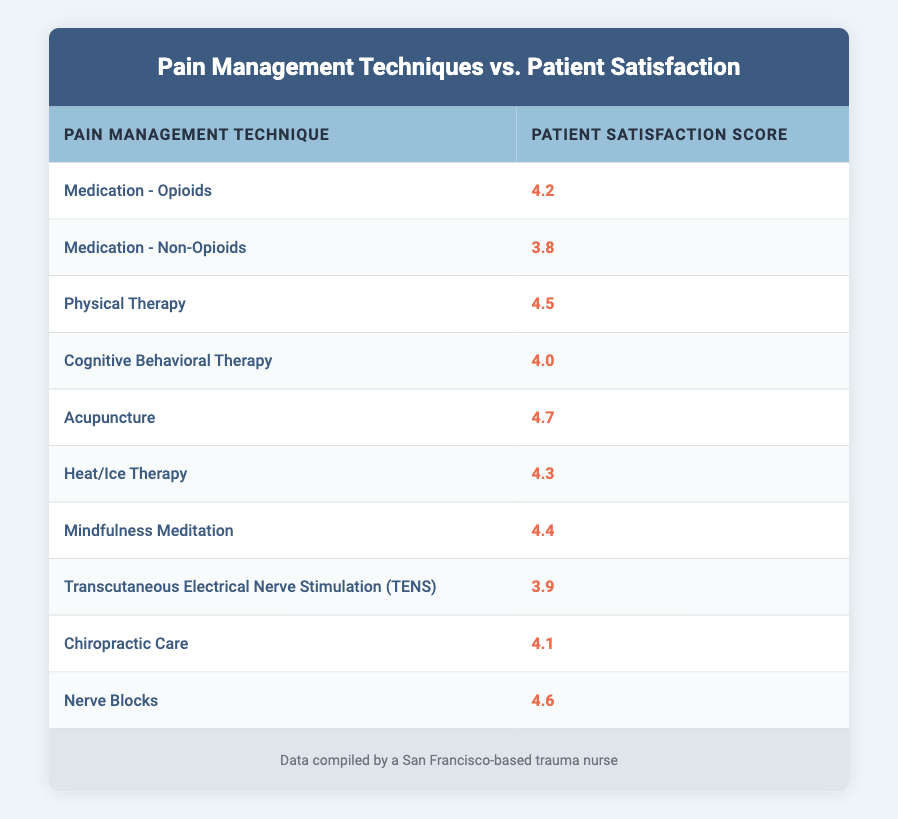What is the patient satisfaction score for Acupuncture? The table lists Acupuncture with a patient satisfaction score of 4.7, which is explicitly stated in the relevant row.
Answer: 4.7 What is the lowest patient satisfaction score among the pain management techniques? By examining the scores presented, the lowest score is 3.8, attributed to Medication - Non-Opioids in the table.
Answer: 3.8 Which pain management technique has a patient satisfaction score of 4.5? Reviewing the table, Physical Therapy is listed with a score of 4.5, thus answering the question directly.
Answer: Physical Therapy Is the patient satisfaction score for Heat/Ice Therapy higher than 4.0? The score for Heat/Ice Therapy is 4.3; since 4.3 is greater than 4.0, the answer is confirmed to be yes.
Answer: Yes What is the average patient satisfaction score for all techniques listed in the table? First, sum all the scores: 4.2 + 3.8 + 4.5 + 4.0 + 4.7 + 4.3 + 4.4 + 3.9 + 4.1 + 4.6 = 44.7. There are 10 techniques, therefore the average is 44.7 ÷ 10 = 4.47.
Answer: 4.47 Which technique offers the highest patient satisfaction score and what is that score? By inspecting the scores, Acupuncture has the highest score of 4.7, which clearly indicates its ranking among the techniques.
Answer: Acupuncture, 4.7 Is it true that Nerve Blocks have a higher satisfaction score than Medication - Opioids? Nerve Blocks have a score of 4.6 and Medication - Opioids has a score of 4.2. Since 4.6 is greater than 4.2, the answer is yes.
Answer: Yes What is the difference in patient satisfaction scores between Acupuncture and Cognitive Behavioral Therapy? Acupuncture has a score of 4.7 and Cognitive Behavioral Therapy has a score of 4.0. The difference is 4.7 - 4.0 = 0.7, thus providing the result.
Answer: 0.7 How many techniques have a patient satisfaction score above 4.4? Scores above 4.4 are 4.5 (Physical Therapy), 4.7 (Acupuncture), 4.4 (Mindfulness Meditation), and 4.6 (Nerve Blocks). That totals 4 techniques with scores exceeding 4.4.
Answer: 4 Which techniques have scores below the average satisfaction score? The average score is 4.47. The techniques below this average are Medication - Non-Opioids (3.8), Transcutaneous Electrical Nerve Stimulation (3.9), and Chiropractic Care (4.1), totaling 3 techniques.
Answer: Medication - Non-Opioids, TENS, Chiropractic Care 